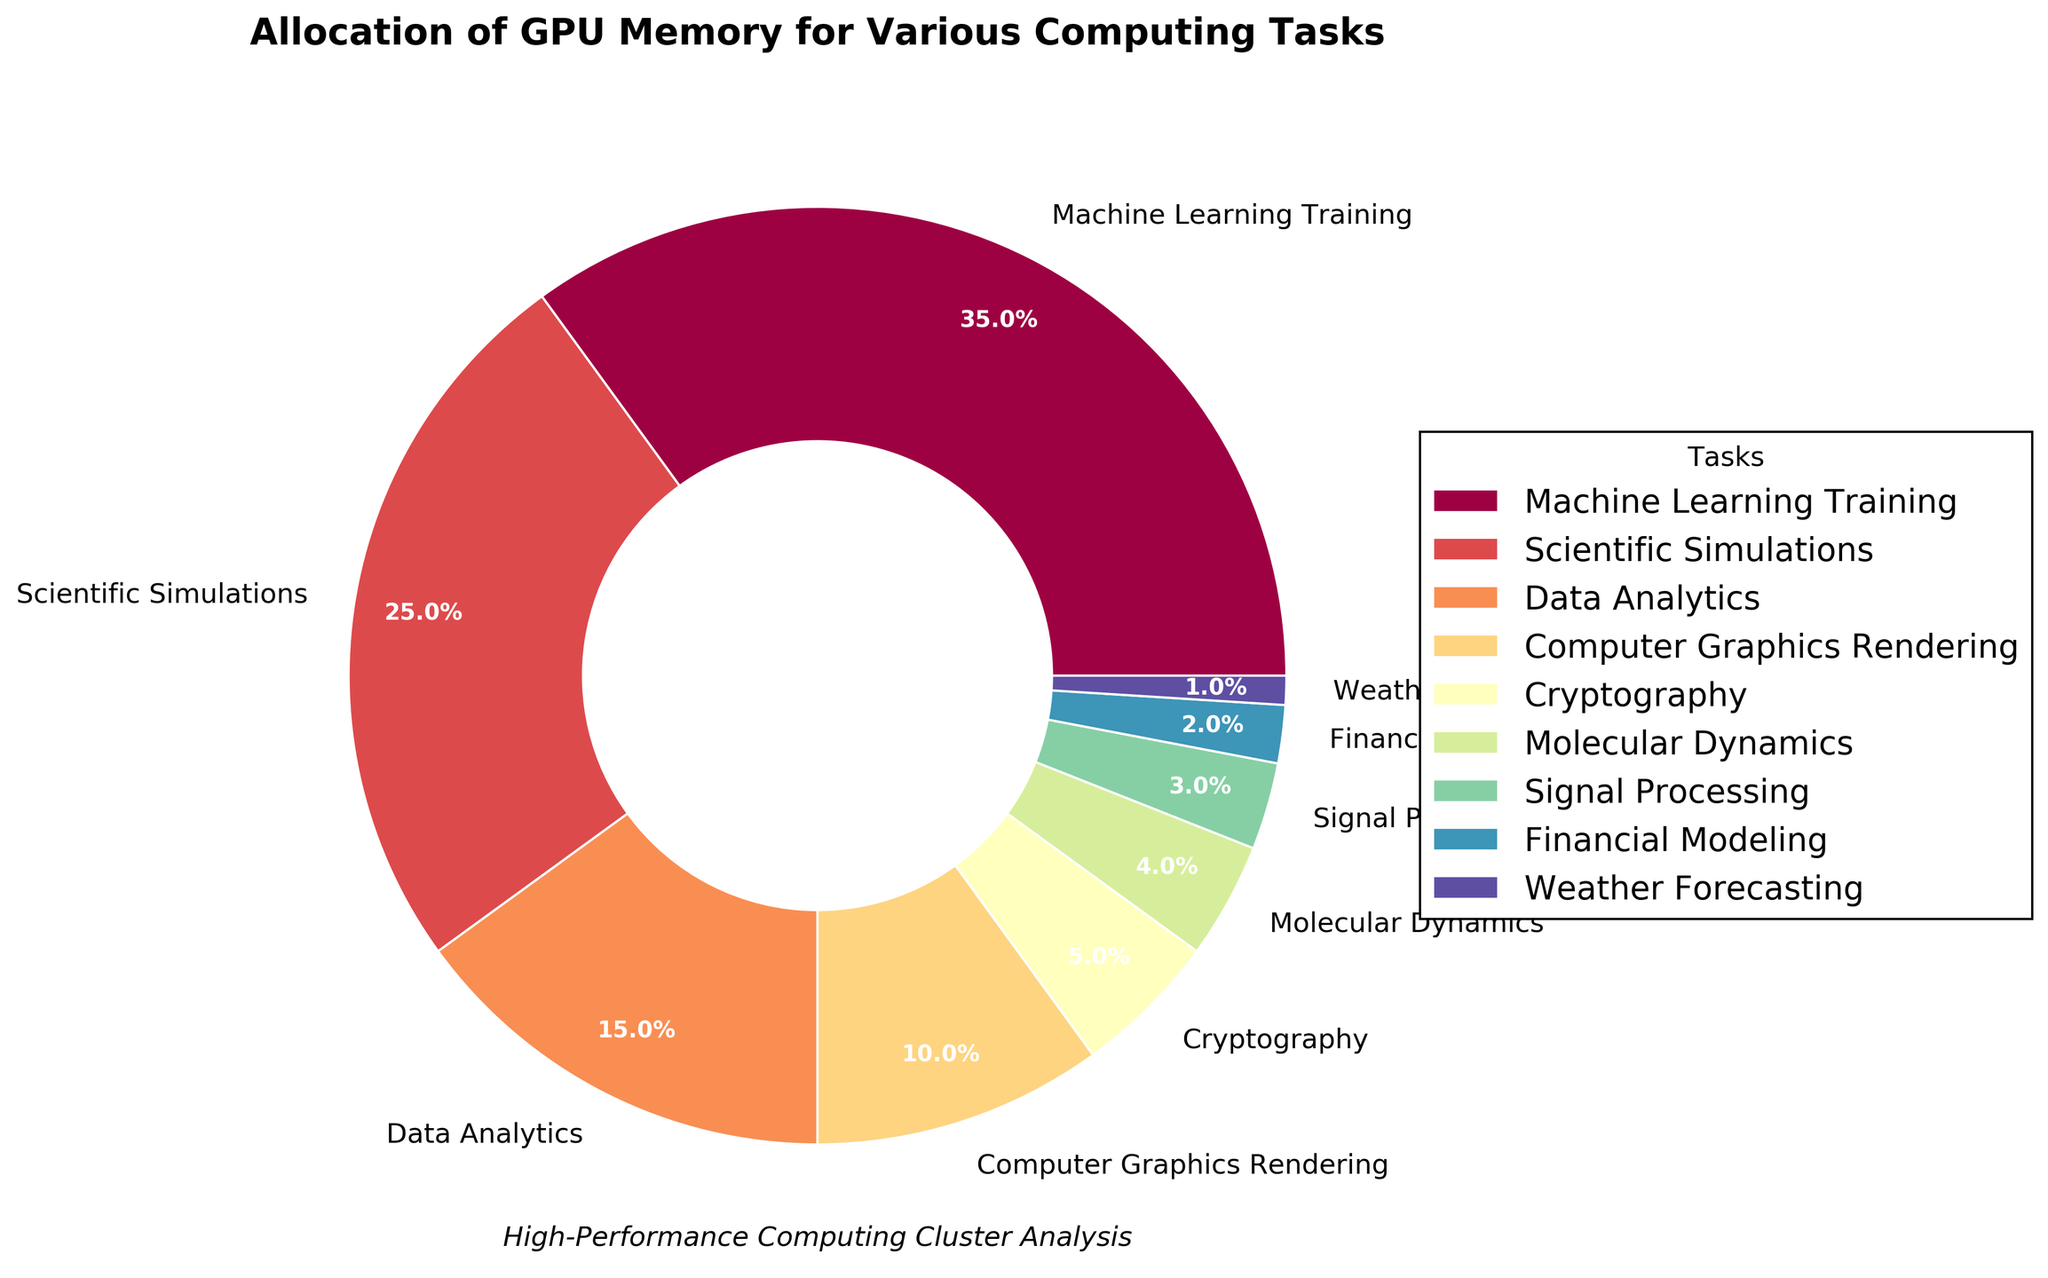What's the task with the highest GPU memory allocation? The pie chart shows different tasks and their corresponding GPU memory allocation percentages. The task with the largest slice represents the highest allocation. According to the figure, Machine Learning Training has the highest, at 35%.
Answer: Machine Learning Training What's the combined percentage of GPU memory allocation for Scientific Simulations and Data Analytics? To find the combined percentage, sum the percentages of Scientific Simulations (25%) and Data Analytics (15%). Adding them gives 25% + 15% = 40%.
Answer: 40% Which task utilizes more GPU memory: Computer Graphics Rendering or Cryptography? By comparing the slices corresponding to Computer Graphics Rendering and Cryptography, we see that Computer Graphics Rendering has a larger percentage (10%) than Cryptography (5%).
Answer: Computer Graphics Rendering What is the difference in GPU memory allocation between Machine Learning Training and Financial Modeling? Subtract the percentage of Financial Modeling (2%) from Machine Learning Training's percentage (35%). The difference is 35% - 2% = 33%.
Answer: 33% Find the average GPU memory allocation percentage for Molecular Dynamics, Signal Processing, and Weather Forecasting. To calculate the average, sum the percentages of Molecular Dynamics (4%), Signal Processing (3%), and Weather Forecasting (1%) and then divide by 3. The sum is 4% + 3% + 1% = 8%. The average is 8% / 3 ≈ 2.67%.
Answer: 2.67% Which tasks, if combined, would make up more than 50% of the GPU memory allocation? We need to find a group of tasks whose combined percentages exceed 50%. By adding the percentages in descending order:
- Machine Learning Training and Scientific Simulations: 35% + 25% = 60%
So, these two tasks alone already add up to more than 50%.
Answer: Machine Learning Training and Scientific Simulations Is Data Analytics allocated more GPU memory than any single task below 4%? The tasks below 4% are Molecular Dynamics (4%), Signal Processing (3%), Financial Modeling (2%), and Weather Forecasting (1%). Data Analytics has 15%, which is indeed more than any of these single tasks.
Answer: Yes How much greater is the GPU allocation of Machine Learning Training compared to the sum of Financial Modeling and Weather Forecasting? First, sum the percentages of Financial Modeling (2%) and Weather Forecasting (1%), which gives 2% + 1% = 3%. Then, subtract this sum from Machine Learning Training's percentage (35%). The difference is 35% - 3% = 32%.
Answer: 32% What's the total percentage of GPU memory allocated to tasks related to scientific computation (i.e., Scientific Simulations and Molecular Dynamics)? Sum the percentages of Scientific Simulations (25%) and Molecular Dynamics (4%). The total is 25% + 4% = 29%.
Answer: 29% 